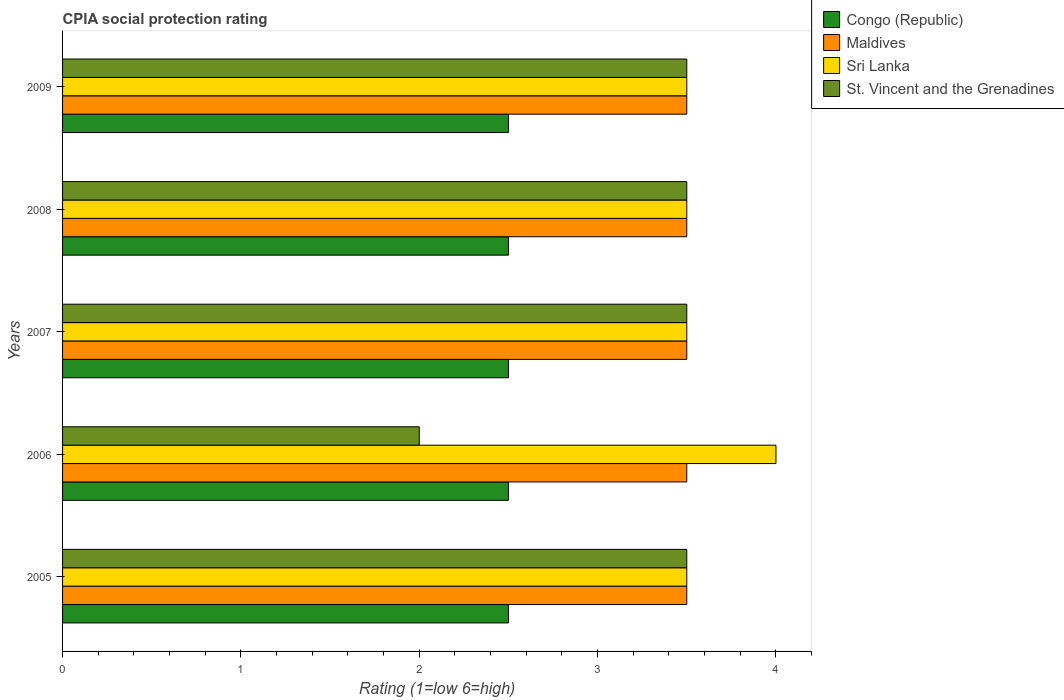How many different coloured bars are there?
Keep it short and to the point. 4. How many groups of bars are there?
Ensure brevity in your answer.  5. Are the number of bars per tick equal to the number of legend labels?
Offer a terse response. Yes. Are the number of bars on each tick of the Y-axis equal?
Offer a very short reply. Yes. What is the label of the 5th group of bars from the top?
Offer a very short reply. 2005. In how many cases, is the number of bars for a given year not equal to the number of legend labels?
Offer a very short reply. 0. Across all years, what is the minimum CPIA rating in Congo (Republic)?
Provide a short and direct response. 2.5. In which year was the CPIA rating in St. Vincent and the Grenadines maximum?
Your answer should be compact. 2005. What is the difference between the CPIA rating in Congo (Republic) in 2005 and that in 2007?
Ensure brevity in your answer.  0. What is the difference between the CPIA rating in Sri Lanka in 2006 and the CPIA rating in Congo (Republic) in 2007?
Your answer should be very brief. 1.5. What is the ratio of the CPIA rating in Congo (Republic) in 2006 to that in 2007?
Your answer should be compact. 1. Is the difference between the CPIA rating in Maldives in 2006 and 2007 greater than the difference between the CPIA rating in Sri Lanka in 2006 and 2007?
Provide a short and direct response. No. What is the difference between the highest and the second highest CPIA rating in Sri Lanka?
Provide a succinct answer. 0.5. Is it the case that in every year, the sum of the CPIA rating in St. Vincent and the Grenadines and CPIA rating in Congo (Republic) is greater than the sum of CPIA rating in Maldives and CPIA rating in Sri Lanka?
Your response must be concise. No. What does the 3rd bar from the top in 2007 represents?
Provide a short and direct response. Maldives. What does the 3rd bar from the bottom in 2008 represents?
Your answer should be very brief. Sri Lanka. Is it the case that in every year, the sum of the CPIA rating in Congo (Republic) and CPIA rating in Maldives is greater than the CPIA rating in Sri Lanka?
Your answer should be compact. Yes. Are all the bars in the graph horizontal?
Keep it short and to the point. Yes. How many years are there in the graph?
Offer a very short reply. 5. What is the difference between two consecutive major ticks on the X-axis?
Give a very brief answer. 1. Are the values on the major ticks of X-axis written in scientific E-notation?
Your answer should be compact. No. How are the legend labels stacked?
Give a very brief answer. Vertical. What is the title of the graph?
Provide a short and direct response. CPIA social protection rating. Does "Ethiopia" appear as one of the legend labels in the graph?
Offer a very short reply. No. What is the label or title of the X-axis?
Your answer should be very brief. Rating (1=low 6=high). What is the Rating (1=low 6=high) of Congo (Republic) in 2005?
Your answer should be very brief. 2.5. What is the Rating (1=low 6=high) in Maldives in 2005?
Your answer should be compact. 3.5. What is the Rating (1=low 6=high) in Sri Lanka in 2005?
Ensure brevity in your answer.  3.5. What is the Rating (1=low 6=high) of Congo (Republic) in 2007?
Keep it short and to the point. 2.5. What is the Rating (1=low 6=high) in Sri Lanka in 2007?
Provide a short and direct response. 3.5. What is the Rating (1=low 6=high) in St. Vincent and the Grenadines in 2007?
Give a very brief answer. 3.5. What is the Rating (1=low 6=high) of Congo (Republic) in 2008?
Ensure brevity in your answer.  2.5. What is the Rating (1=low 6=high) in Maldives in 2009?
Keep it short and to the point. 3.5. What is the Rating (1=low 6=high) of Sri Lanka in 2009?
Your answer should be compact. 3.5. Across all years, what is the maximum Rating (1=low 6=high) in Congo (Republic)?
Offer a terse response. 2.5. Across all years, what is the maximum Rating (1=low 6=high) of Maldives?
Ensure brevity in your answer.  3.5. Across all years, what is the minimum Rating (1=low 6=high) in Congo (Republic)?
Provide a succinct answer. 2.5. Across all years, what is the minimum Rating (1=low 6=high) of St. Vincent and the Grenadines?
Provide a short and direct response. 2. What is the total Rating (1=low 6=high) in Congo (Republic) in the graph?
Your answer should be compact. 12.5. What is the difference between the Rating (1=low 6=high) of Congo (Republic) in 2005 and that in 2006?
Give a very brief answer. 0. What is the difference between the Rating (1=low 6=high) in Congo (Republic) in 2005 and that in 2007?
Make the answer very short. 0. What is the difference between the Rating (1=low 6=high) of Maldives in 2005 and that in 2007?
Provide a succinct answer. 0. What is the difference between the Rating (1=low 6=high) of Sri Lanka in 2005 and that in 2009?
Offer a terse response. 0. What is the difference between the Rating (1=low 6=high) of St. Vincent and the Grenadines in 2005 and that in 2009?
Give a very brief answer. 0. What is the difference between the Rating (1=low 6=high) of Congo (Republic) in 2006 and that in 2007?
Offer a terse response. 0. What is the difference between the Rating (1=low 6=high) of Maldives in 2006 and that in 2007?
Your answer should be compact. 0. What is the difference between the Rating (1=low 6=high) in Sri Lanka in 2006 and that in 2007?
Your answer should be very brief. 0.5. What is the difference between the Rating (1=low 6=high) in Congo (Republic) in 2006 and that in 2008?
Give a very brief answer. 0. What is the difference between the Rating (1=low 6=high) of Maldives in 2006 and that in 2008?
Give a very brief answer. 0. What is the difference between the Rating (1=low 6=high) of Maldives in 2006 and that in 2009?
Provide a short and direct response. 0. What is the difference between the Rating (1=low 6=high) of Sri Lanka in 2006 and that in 2009?
Provide a short and direct response. 0.5. What is the difference between the Rating (1=low 6=high) in Congo (Republic) in 2007 and that in 2008?
Your response must be concise. 0. What is the difference between the Rating (1=low 6=high) of Congo (Republic) in 2007 and that in 2009?
Offer a very short reply. 0. What is the difference between the Rating (1=low 6=high) of Maldives in 2007 and that in 2009?
Your answer should be compact. 0. What is the difference between the Rating (1=low 6=high) of Congo (Republic) in 2008 and that in 2009?
Provide a short and direct response. 0. What is the difference between the Rating (1=low 6=high) of Sri Lanka in 2008 and that in 2009?
Your answer should be very brief. 0. What is the difference between the Rating (1=low 6=high) of Congo (Republic) in 2005 and the Rating (1=low 6=high) of St. Vincent and the Grenadines in 2006?
Provide a succinct answer. 0.5. What is the difference between the Rating (1=low 6=high) of Maldives in 2005 and the Rating (1=low 6=high) of Sri Lanka in 2006?
Make the answer very short. -0.5. What is the difference between the Rating (1=low 6=high) in Sri Lanka in 2005 and the Rating (1=low 6=high) in St. Vincent and the Grenadines in 2006?
Your answer should be very brief. 1.5. What is the difference between the Rating (1=low 6=high) of Congo (Republic) in 2005 and the Rating (1=low 6=high) of Sri Lanka in 2007?
Your response must be concise. -1. What is the difference between the Rating (1=low 6=high) in Maldives in 2005 and the Rating (1=low 6=high) in Sri Lanka in 2007?
Ensure brevity in your answer.  0. What is the difference between the Rating (1=low 6=high) in Sri Lanka in 2005 and the Rating (1=low 6=high) in St. Vincent and the Grenadines in 2007?
Your response must be concise. 0. What is the difference between the Rating (1=low 6=high) of Congo (Republic) in 2005 and the Rating (1=low 6=high) of Maldives in 2008?
Provide a short and direct response. -1. What is the difference between the Rating (1=low 6=high) in Maldives in 2005 and the Rating (1=low 6=high) in Sri Lanka in 2008?
Make the answer very short. 0. What is the difference between the Rating (1=low 6=high) in Maldives in 2005 and the Rating (1=low 6=high) in St. Vincent and the Grenadines in 2008?
Give a very brief answer. 0. What is the difference between the Rating (1=low 6=high) of Sri Lanka in 2005 and the Rating (1=low 6=high) of St. Vincent and the Grenadines in 2008?
Provide a short and direct response. 0. What is the difference between the Rating (1=low 6=high) of Congo (Republic) in 2005 and the Rating (1=low 6=high) of Sri Lanka in 2009?
Provide a succinct answer. -1. What is the difference between the Rating (1=low 6=high) in Sri Lanka in 2005 and the Rating (1=low 6=high) in St. Vincent and the Grenadines in 2009?
Provide a short and direct response. 0. What is the difference between the Rating (1=low 6=high) of Congo (Republic) in 2006 and the Rating (1=low 6=high) of Sri Lanka in 2007?
Your answer should be very brief. -1. What is the difference between the Rating (1=low 6=high) of Maldives in 2006 and the Rating (1=low 6=high) of Sri Lanka in 2007?
Make the answer very short. 0. What is the difference between the Rating (1=low 6=high) in Congo (Republic) in 2006 and the Rating (1=low 6=high) in Maldives in 2008?
Make the answer very short. -1. What is the difference between the Rating (1=low 6=high) of Sri Lanka in 2006 and the Rating (1=low 6=high) of St. Vincent and the Grenadines in 2008?
Offer a terse response. 0.5. What is the difference between the Rating (1=low 6=high) of Congo (Republic) in 2006 and the Rating (1=low 6=high) of Sri Lanka in 2009?
Your answer should be compact. -1. What is the difference between the Rating (1=low 6=high) of Maldives in 2006 and the Rating (1=low 6=high) of St. Vincent and the Grenadines in 2009?
Ensure brevity in your answer.  0. What is the difference between the Rating (1=low 6=high) of Sri Lanka in 2006 and the Rating (1=low 6=high) of St. Vincent and the Grenadines in 2009?
Provide a succinct answer. 0.5. What is the difference between the Rating (1=low 6=high) of Maldives in 2007 and the Rating (1=low 6=high) of Sri Lanka in 2008?
Provide a succinct answer. 0. What is the difference between the Rating (1=low 6=high) in Maldives in 2007 and the Rating (1=low 6=high) in St. Vincent and the Grenadines in 2008?
Provide a short and direct response. 0. What is the difference between the Rating (1=low 6=high) of Congo (Republic) in 2007 and the Rating (1=low 6=high) of Sri Lanka in 2009?
Your answer should be very brief. -1. What is the difference between the Rating (1=low 6=high) of Maldives in 2007 and the Rating (1=low 6=high) of Sri Lanka in 2009?
Keep it short and to the point. 0. What is the difference between the Rating (1=low 6=high) in Maldives in 2007 and the Rating (1=low 6=high) in St. Vincent and the Grenadines in 2009?
Offer a terse response. 0. What is the difference between the Rating (1=low 6=high) of Sri Lanka in 2007 and the Rating (1=low 6=high) of St. Vincent and the Grenadines in 2009?
Your answer should be very brief. 0. What is the difference between the Rating (1=low 6=high) of Congo (Republic) in 2008 and the Rating (1=low 6=high) of Sri Lanka in 2009?
Your answer should be compact. -1. What is the difference between the Rating (1=low 6=high) in Congo (Republic) in 2008 and the Rating (1=low 6=high) in St. Vincent and the Grenadines in 2009?
Provide a short and direct response. -1. What is the difference between the Rating (1=low 6=high) in Maldives in 2008 and the Rating (1=low 6=high) in Sri Lanka in 2009?
Offer a terse response. 0. What is the difference between the Rating (1=low 6=high) in Maldives in 2008 and the Rating (1=low 6=high) in St. Vincent and the Grenadines in 2009?
Keep it short and to the point. 0. What is the difference between the Rating (1=low 6=high) in Sri Lanka in 2008 and the Rating (1=low 6=high) in St. Vincent and the Grenadines in 2009?
Provide a succinct answer. 0. What is the average Rating (1=low 6=high) of Congo (Republic) per year?
Make the answer very short. 2.5. What is the average Rating (1=low 6=high) in Sri Lanka per year?
Your response must be concise. 3.6. What is the average Rating (1=low 6=high) in St. Vincent and the Grenadines per year?
Offer a terse response. 3.2. In the year 2005, what is the difference between the Rating (1=low 6=high) in Sri Lanka and Rating (1=low 6=high) in St. Vincent and the Grenadines?
Your answer should be compact. 0. In the year 2006, what is the difference between the Rating (1=low 6=high) of Congo (Republic) and Rating (1=low 6=high) of Sri Lanka?
Ensure brevity in your answer.  -1.5. In the year 2006, what is the difference between the Rating (1=low 6=high) of Congo (Republic) and Rating (1=low 6=high) of St. Vincent and the Grenadines?
Make the answer very short. 0.5. In the year 2007, what is the difference between the Rating (1=low 6=high) of Congo (Republic) and Rating (1=low 6=high) of St. Vincent and the Grenadines?
Your answer should be compact. -1. In the year 2007, what is the difference between the Rating (1=low 6=high) in Maldives and Rating (1=low 6=high) in Sri Lanka?
Keep it short and to the point. 0. In the year 2008, what is the difference between the Rating (1=low 6=high) in Congo (Republic) and Rating (1=low 6=high) in Maldives?
Keep it short and to the point. -1. In the year 2008, what is the difference between the Rating (1=low 6=high) of Congo (Republic) and Rating (1=low 6=high) of Sri Lanka?
Provide a short and direct response. -1. In the year 2008, what is the difference between the Rating (1=low 6=high) of Maldives and Rating (1=low 6=high) of St. Vincent and the Grenadines?
Ensure brevity in your answer.  0. In the year 2008, what is the difference between the Rating (1=low 6=high) in Sri Lanka and Rating (1=low 6=high) in St. Vincent and the Grenadines?
Offer a very short reply. 0. In the year 2009, what is the difference between the Rating (1=low 6=high) in Congo (Republic) and Rating (1=low 6=high) in St. Vincent and the Grenadines?
Your answer should be very brief. -1. In the year 2009, what is the difference between the Rating (1=low 6=high) in Maldives and Rating (1=low 6=high) in Sri Lanka?
Your answer should be compact. 0. What is the ratio of the Rating (1=low 6=high) in Maldives in 2005 to that in 2006?
Your answer should be very brief. 1. What is the ratio of the Rating (1=low 6=high) of Sri Lanka in 2005 to that in 2006?
Your response must be concise. 0.88. What is the ratio of the Rating (1=low 6=high) of Maldives in 2005 to that in 2007?
Ensure brevity in your answer.  1. What is the ratio of the Rating (1=low 6=high) of St. Vincent and the Grenadines in 2005 to that in 2007?
Your answer should be very brief. 1. What is the ratio of the Rating (1=low 6=high) in Congo (Republic) in 2005 to that in 2008?
Your answer should be compact. 1. What is the ratio of the Rating (1=low 6=high) in Sri Lanka in 2005 to that in 2008?
Keep it short and to the point. 1. What is the ratio of the Rating (1=low 6=high) of St. Vincent and the Grenadines in 2005 to that in 2008?
Your answer should be very brief. 1. What is the ratio of the Rating (1=low 6=high) in Sri Lanka in 2005 to that in 2009?
Provide a short and direct response. 1. What is the ratio of the Rating (1=low 6=high) in Congo (Republic) in 2006 to that in 2007?
Make the answer very short. 1. What is the ratio of the Rating (1=low 6=high) in Maldives in 2006 to that in 2007?
Offer a terse response. 1. What is the ratio of the Rating (1=low 6=high) of Sri Lanka in 2006 to that in 2008?
Make the answer very short. 1.14. What is the ratio of the Rating (1=low 6=high) of St. Vincent and the Grenadines in 2006 to that in 2008?
Provide a short and direct response. 0.57. What is the ratio of the Rating (1=low 6=high) in Sri Lanka in 2007 to that in 2008?
Offer a very short reply. 1. What is the ratio of the Rating (1=low 6=high) in Congo (Republic) in 2007 to that in 2009?
Provide a short and direct response. 1. What is the ratio of the Rating (1=low 6=high) in Sri Lanka in 2007 to that in 2009?
Your response must be concise. 1. What is the ratio of the Rating (1=low 6=high) of Maldives in 2008 to that in 2009?
Your response must be concise. 1. What is the ratio of the Rating (1=low 6=high) of Sri Lanka in 2008 to that in 2009?
Keep it short and to the point. 1. What is the ratio of the Rating (1=low 6=high) of St. Vincent and the Grenadines in 2008 to that in 2009?
Offer a terse response. 1. What is the difference between the highest and the lowest Rating (1=low 6=high) of Maldives?
Your response must be concise. 0. 